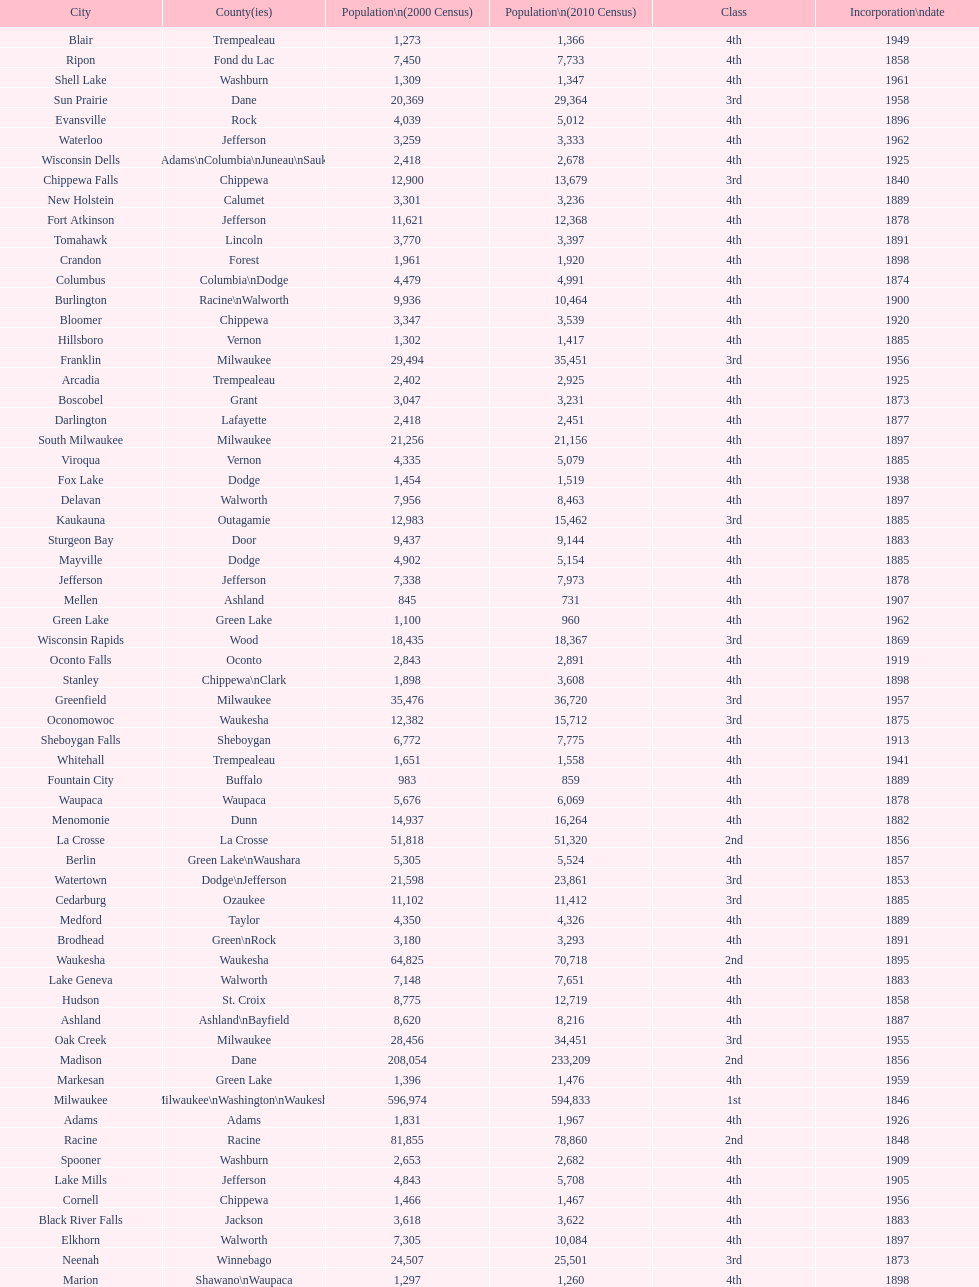Which city has the most population in the 2010 census? Milwaukee. 